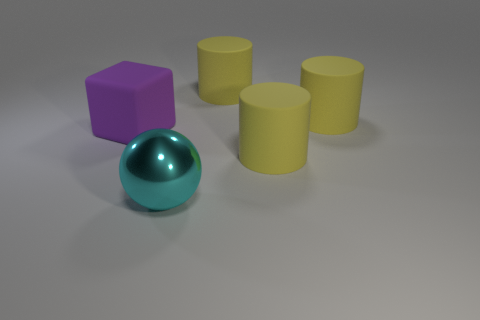Is there any other thing that is made of the same material as the large sphere?
Make the answer very short. No. Does the big metal object have the same shape as the large purple object?
Your response must be concise. No. Do the big matte object that is left of the cyan sphere and the shiny object have the same shape?
Offer a terse response. No. What number of objects are yellow rubber things or rubber cubes?
Ensure brevity in your answer.  4. Do the object left of the big cyan shiny ball and the big cyan ball have the same material?
Offer a very short reply. No. What number of cylinders are either matte things or big objects?
Give a very brief answer. 3. Is the number of large purple matte blocks that are to the left of the purple thing the same as the number of objects behind the big metallic thing?
Provide a short and direct response. No. There is a thing that is both in front of the matte cube and on the right side of the big ball; what is its size?
Your response must be concise. Large. Are there any cubes to the left of the big block?
Make the answer very short. No. How many things are either large objects behind the cyan thing or blue matte things?
Ensure brevity in your answer.  4. 